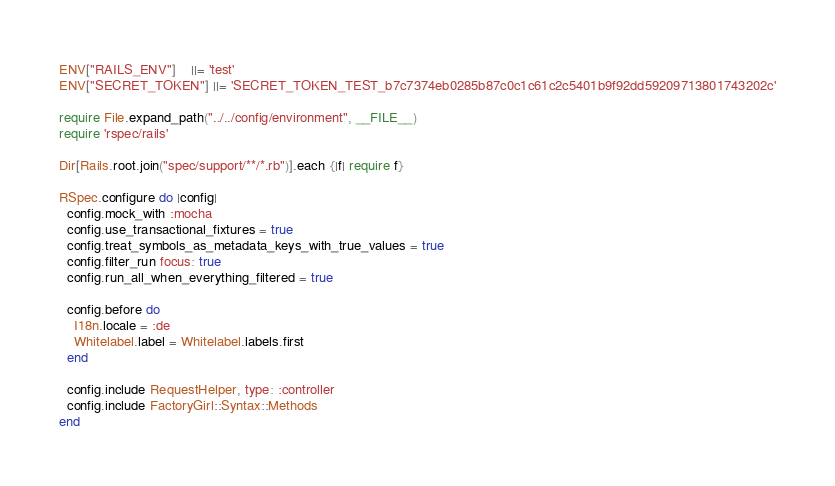<code> <loc_0><loc_0><loc_500><loc_500><_Ruby_>ENV["RAILS_ENV"]    ||= 'test'
ENV["SECRET_TOKEN"] ||= 'SECRET_TOKEN_TEST_b7c7374eb0285b87c0c1c61c2c5401b9f92dd59209713801743202c'

require File.expand_path("../../config/environment", __FILE__)
require 'rspec/rails'

Dir[Rails.root.join("spec/support/**/*.rb")].each {|f| require f}

RSpec.configure do |config|
  config.mock_with :mocha
  config.use_transactional_fixtures = true
  config.treat_symbols_as_metadata_keys_with_true_values = true
  config.filter_run focus: true
  config.run_all_when_everything_filtered = true

  config.before do
    I18n.locale = :de
    Whitelabel.label = Whitelabel.labels.first
  end

  config.include RequestHelper, type: :controller
  config.include FactoryGirl::Syntax::Methods
end
</code> 